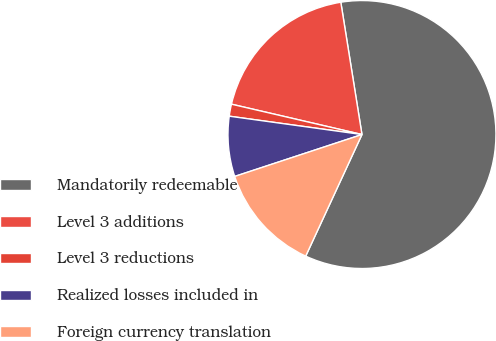Convert chart to OTSL. <chart><loc_0><loc_0><loc_500><loc_500><pie_chart><fcel>Mandatorily redeemable<fcel>Level 3 additions<fcel>Level 3 reductions<fcel>Realized losses included in<fcel>Foreign currency translation<nl><fcel>59.42%<fcel>18.84%<fcel>1.45%<fcel>7.25%<fcel>13.04%<nl></chart> 